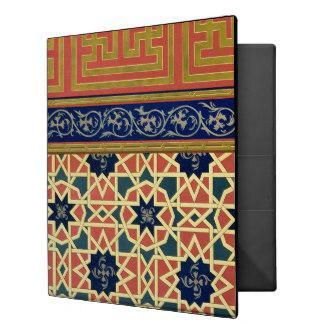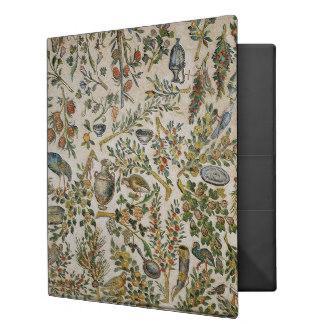The first image is the image on the left, the second image is the image on the right. Given the left and right images, does the statement "There is a single floral binder in the image on the right." hold true? Answer yes or no. Yes. The first image is the image on the left, the second image is the image on the right. Analyze the images presented: Is the assertion "One image shows exactly five binders displayed side-by-side." valid? Answer yes or no. No. 